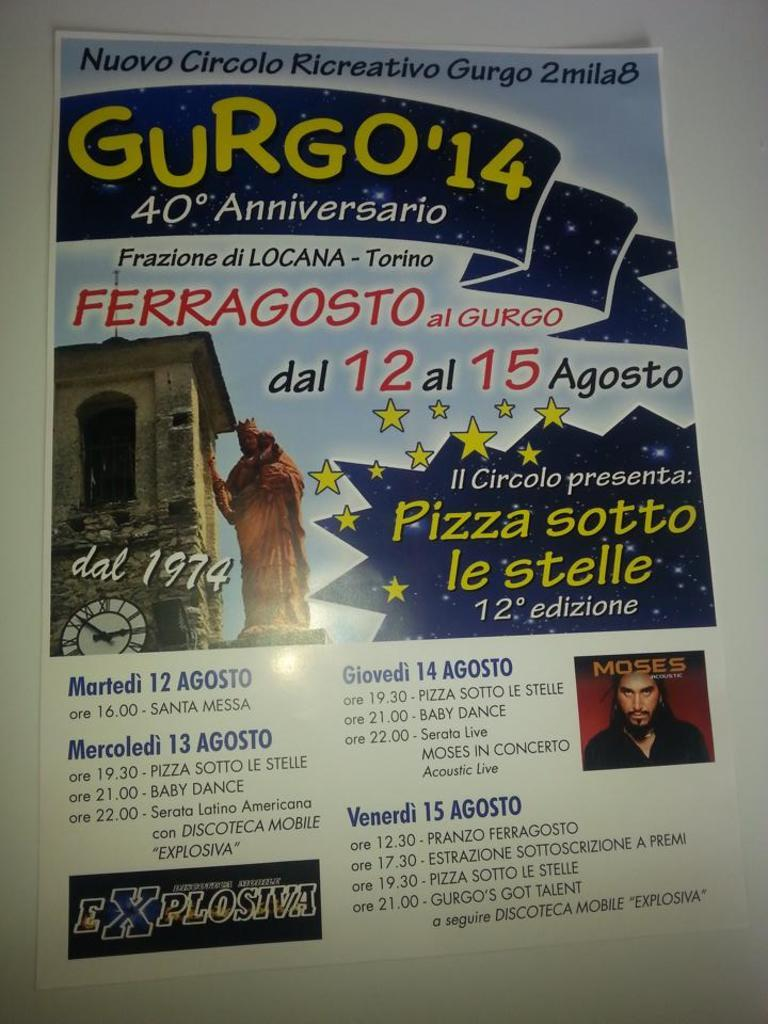What is the main feature of the image? There is a poster in the image. What types of information are present on the poster? The poster contains words, numbers, and pictures. Can you describe the pictures on the poster? There is a picture of a person, a statue, and a clock tower on the poster. What color is the toothbrush used by the person in the image? There is no toothbrush present in the image. What is the tendency of the pen in the image? There is no pen present in the image. 